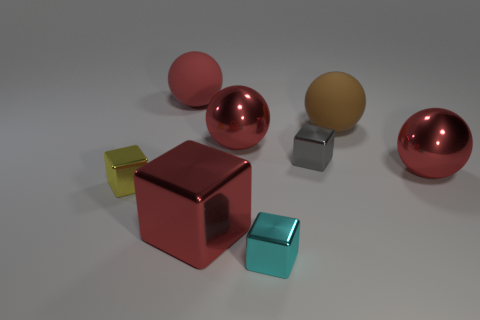Subtract all green cubes. How many red balls are left? 3 Add 1 tiny cyan things. How many objects exist? 9 Add 4 large red metallic cubes. How many large red metallic cubes are left? 5 Add 8 cyan metal things. How many cyan metal things exist? 9 Subtract 1 red balls. How many objects are left? 7 Subtract all large yellow matte objects. Subtract all big red balls. How many objects are left? 5 